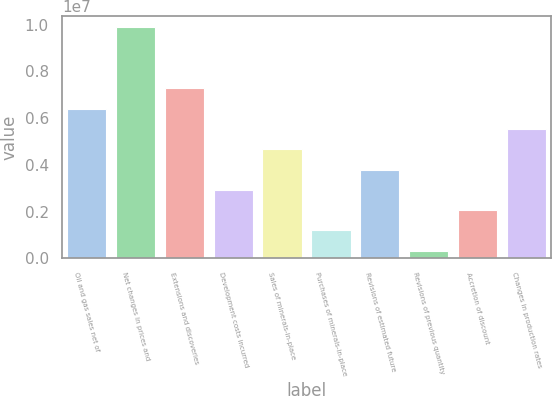<chart> <loc_0><loc_0><loc_500><loc_500><bar_chart><fcel>Oil and gas sales net of<fcel>Net changes in prices and<fcel>Extensions and discoveries<fcel>Development costs incurred<fcel>Sales of minerals-in-place<fcel>Purchases of minerals-in-place<fcel>Revisions of estimated future<fcel>Revisions of previous quantity<fcel>Accretion of discount<fcel>Changes in production rates<nl><fcel>6.40856e+06<fcel>9.88633e+06<fcel>7.278e+06<fcel>2.93079e+06<fcel>4.66968e+06<fcel>1.19191e+06<fcel>3.80024e+06<fcel>322470<fcel>2.06135e+06<fcel>5.53912e+06<nl></chart> 